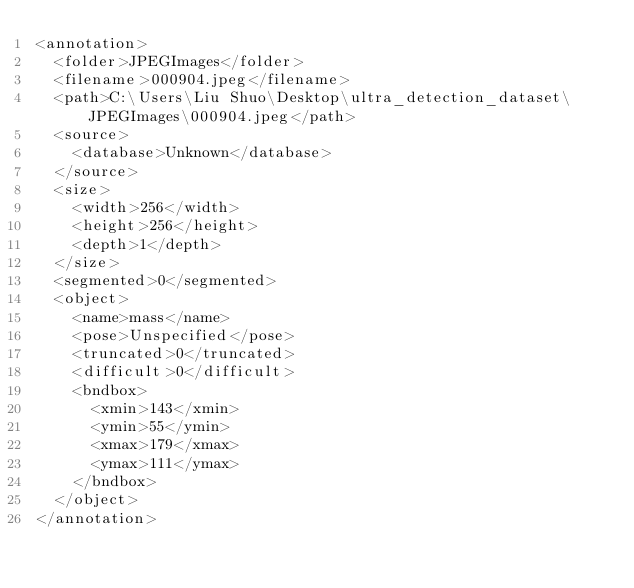Convert code to text. <code><loc_0><loc_0><loc_500><loc_500><_XML_><annotation>
	<folder>JPEGImages</folder>
	<filename>000904.jpeg</filename>
	<path>C:\Users\Liu Shuo\Desktop\ultra_detection_dataset\JPEGImages\000904.jpeg</path>
	<source>
		<database>Unknown</database>
	</source>
	<size>
		<width>256</width>
		<height>256</height>
		<depth>1</depth>
	</size>
	<segmented>0</segmented>
	<object>
		<name>mass</name>
		<pose>Unspecified</pose>
		<truncated>0</truncated>
		<difficult>0</difficult>
		<bndbox>
			<xmin>143</xmin>
			<ymin>55</ymin>
			<xmax>179</xmax>
			<ymax>111</ymax>
		</bndbox>
	</object>
</annotation>
</code> 